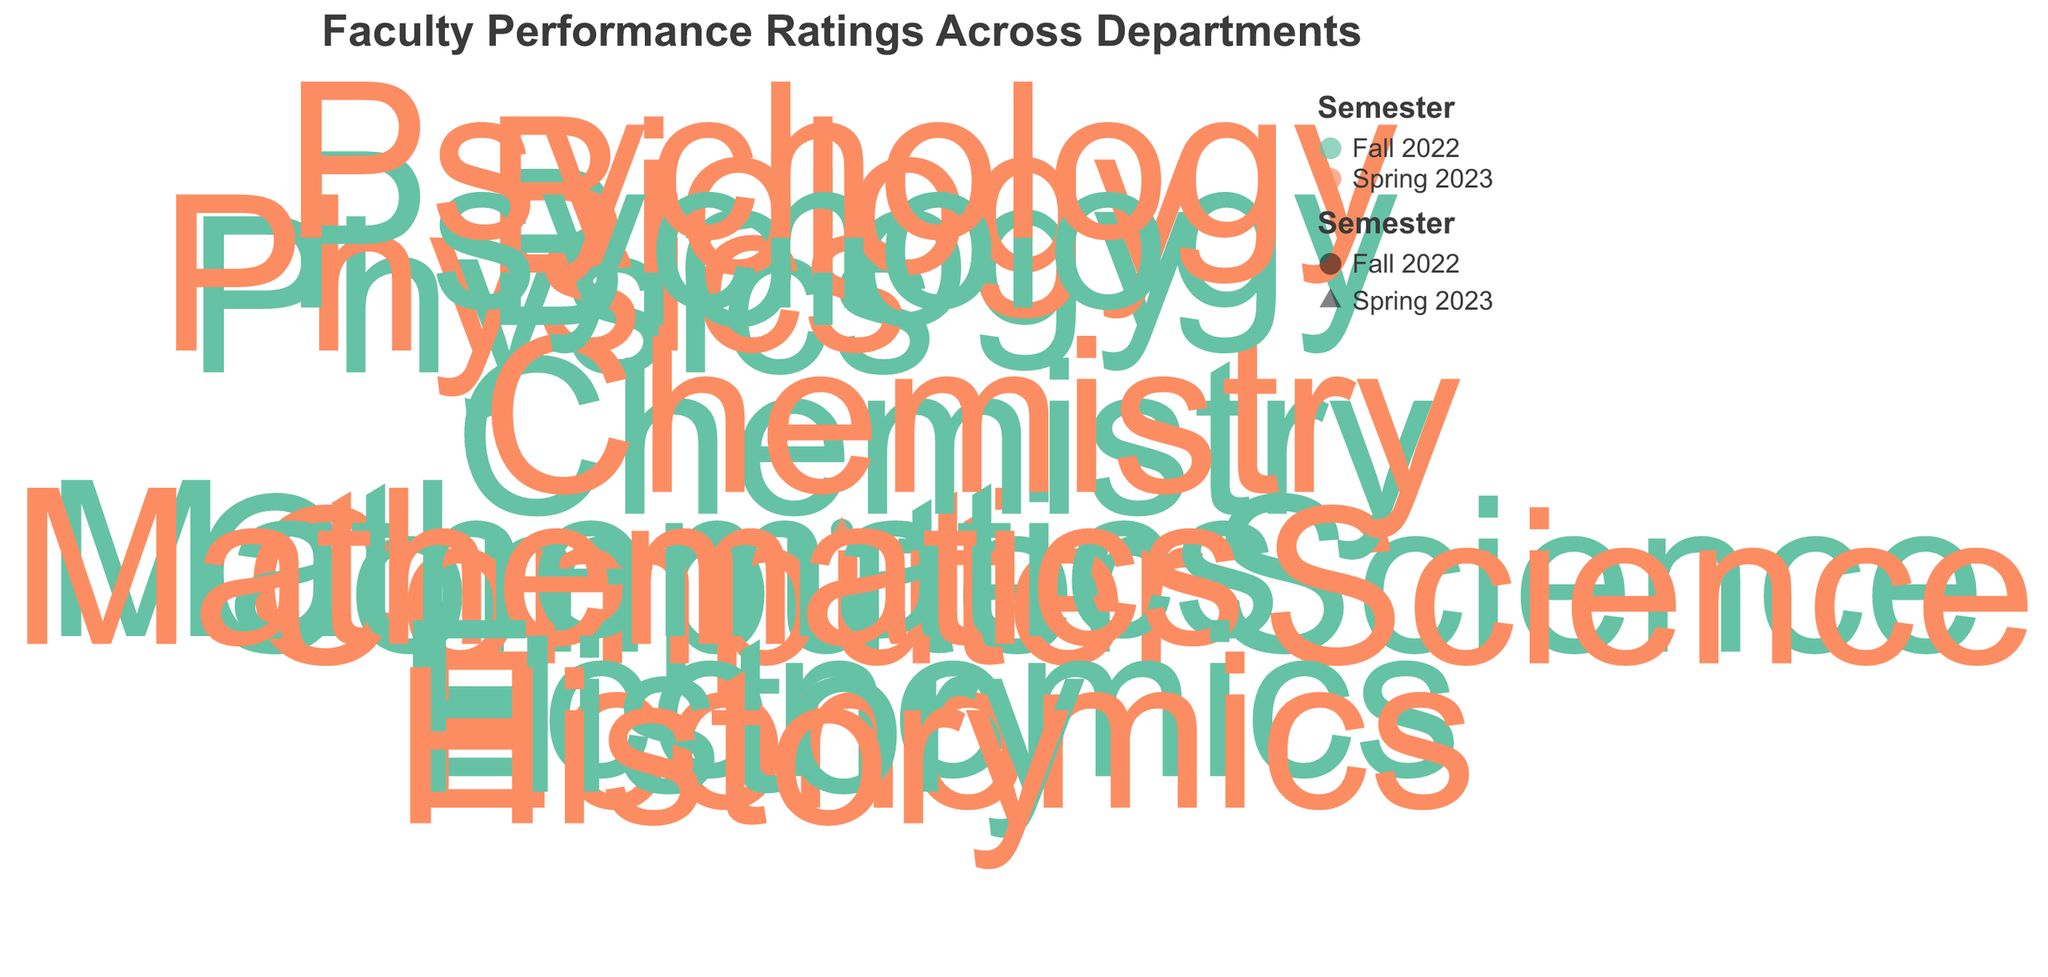What is the title of the chart? The title is displayed at the top of the chart and reads "Faculty Performance Ratings Across Departments", which provides context for the type of data visualized.
Answer: Faculty Performance Ratings Across Departments Which department had the highest performance rating in Spring 2023? By looking at the radial positions and lengths relative to the performance ratings, the Physics department (Dr. Wilson) had the highest rating with a value of 90 in Spring 2023.
Answer: Physics What shape represents the Spring 2023 semester in the plot? The plot uses a legend to differentiate between semesters, and based on the legend, the Spring 2023 semester is represented by a triangle.
Answer: Triangle Which two departments showed the most significant increase in performance ratings from Fall 2022 to Spring 2023? By comparing the distances of points within the same department for different semesters, Biology and Psychology showed significant increases. From Fall 2022 to Spring 2023, Biology went from 83 to 86 (+3) and Psychology from 84 to 88 (+4).
Answer: Biology and Psychology What is the median performance rating for all faculty members in Fall 2022? List all Fall 2022 ratings: 82, 78, 88, 75, 83, 79, 84, 80. Arrange in ascending order: 75, 78, 79, 80, 82, 83, 84, 88. The median is the average of the 4th and 5th values: (80+82)/2 = 81.
Answer: 81 Are there any departments with equal performance ratings in Fall 2022 and Spring 2023? By comparing the ratings for each department across semesters, none of the departments have equal ratings in both semesters.
Answer: No Which department had the lowest performance rating in Fall 2022, and what was it? Observe the radial values for Fall 2022, and Chemistry (Dr. Martinez) had the lowest performance rating of 75.
Answer: Chemistry, 75 How many departments are represented in the plot? By counting the unique department labels displayed around the radial axis, there are a total of seven departments: Computer Science, Mathematics, Physics, Chemistry, Biology, Economics, and Psychology.
Answer: Seven What is the average performance rating for History across both semesters? The ratings for History are 80 in Fall 2022 and 82 in Spring 2023. The average is calculated as (80 + 82)/2 = 81.
Answer: 81 How do the performance ratings for Economics compare between Fall 2022 and Spring 2023? The performance rating for Economics is 79 in Fall 2022 and 81 in Spring 2023, showing an increase by comparing the two values (81 - 79 = 2).
Answer: Increased by 2 